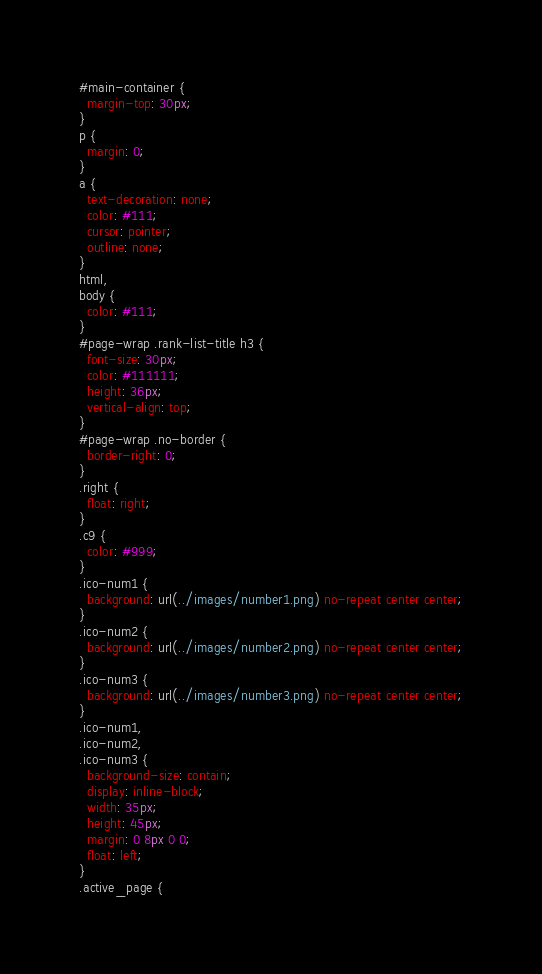Convert code to text. <code><loc_0><loc_0><loc_500><loc_500><_CSS_>#main-container {
  margin-top: 30px;
}
p {
  margin: 0;
}
a {
  text-decoration: none;
  color: #111;
  cursor: pointer;
  outline: none;
}
html,
body {
  color: #111;
}
#page-wrap .rank-list-title h3 {
  font-size: 30px;
  color: #111111;
  height: 36px;
  vertical-align: top;
}
#page-wrap .no-border {
  border-right: 0;
}
.right {
  float: right;
}
.c9 {
  color: #999;
}
.ico-num1 {
  background: url(../images/number1.png) no-repeat center center;
}
.ico-num2 {
  background: url(../images/number2.png) no-repeat center center;
}
.ico-num3 {
  background: url(../images/number3.png) no-repeat center center;
}
.ico-num1,
.ico-num2,
.ico-num3 {
  background-size: contain;
  display: inline-block;
  width: 35px;
  height: 45px;
  margin: 0 8px 0 0;
  float: left;
}
.active_page {</code> 